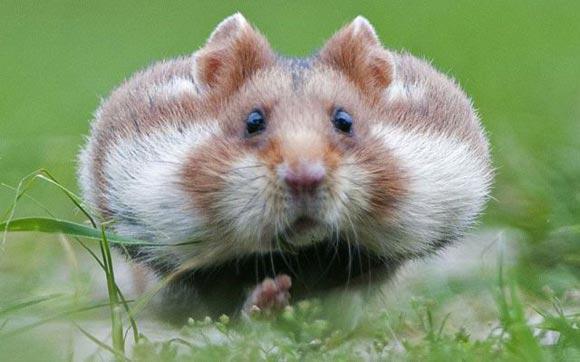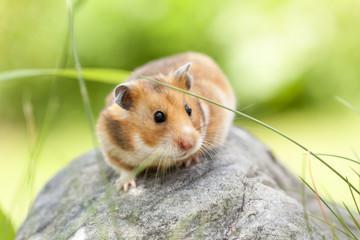The first image is the image on the left, the second image is the image on the right. Examine the images to the left and right. Is the description "One of the animals is sitting on a rock." accurate? Answer yes or no. Yes. 